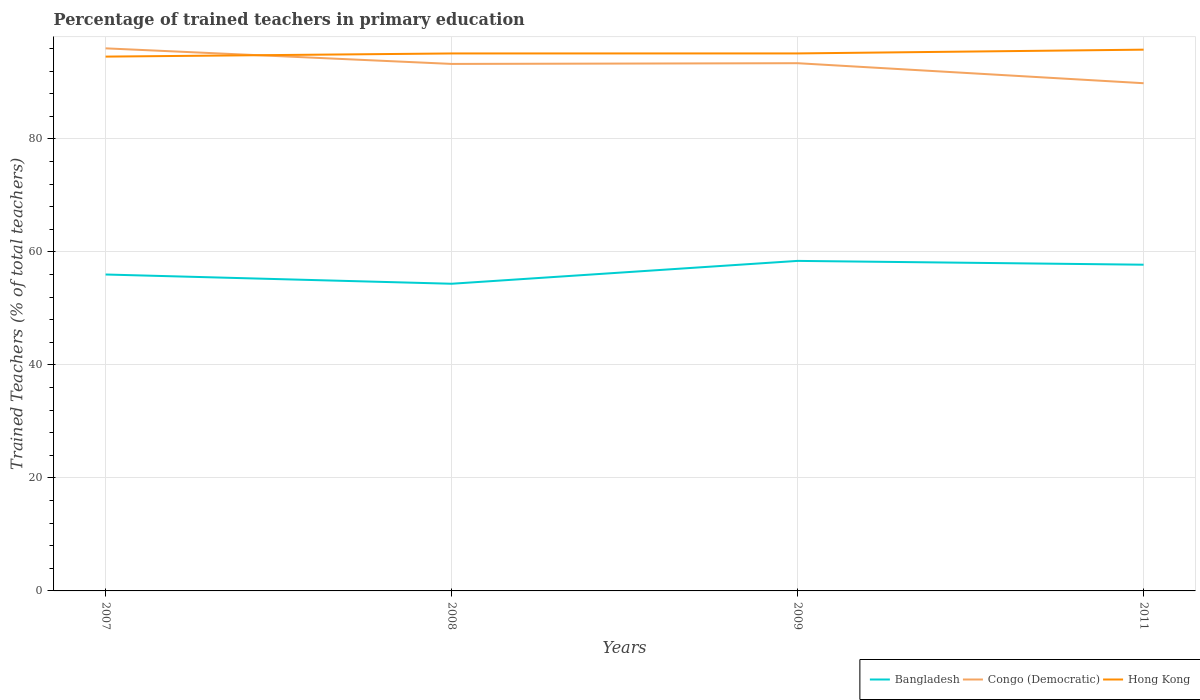How many different coloured lines are there?
Your answer should be very brief. 3. Does the line corresponding to Bangladesh intersect with the line corresponding to Hong Kong?
Make the answer very short. No. Across all years, what is the maximum percentage of trained teachers in Bangladesh?
Offer a very short reply. 54.36. What is the total percentage of trained teachers in Hong Kong in the graph?
Your answer should be very brief. -0.67. What is the difference between the highest and the second highest percentage of trained teachers in Congo (Democratic)?
Provide a short and direct response. 6.17. Is the percentage of trained teachers in Congo (Democratic) strictly greater than the percentage of trained teachers in Hong Kong over the years?
Your response must be concise. No. How many lines are there?
Give a very brief answer. 3. How many years are there in the graph?
Give a very brief answer. 4. What is the difference between two consecutive major ticks on the Y-axis?
Make the answer very short. 20. Are the values on the major ticks of Y-axis written in scientific E-notation?
Provide a succinct answer. No. Where does the legend appear in the graph?
Ensure brevity in your answer.  Bottom right. How many legend labels are there?
Your answer should be very brief. 3. What is the title of the graph?
Offer a terse response. Percentage of trained teachers in primary education. What is the label or title of the Y-axis?
Keep it short and to the point. Trained Teachers (% of total teachers). What is the Trained Teachers (% of total teachers) in Bangladesh in 2007?
Provide a succinct answer. 56. What is the Trained Teachers (% of total teachers) of Congo (Democratic) in 2007?
Your answer should be compact. 96.02. What is the Trained Teachers (% of total teachers) in Hong Kong in 2007?
Give a very brief answer. 94.56. What is the Trained Teachers (% of total teachers) of Bangladesh in 2008?
Your response must be concise. 54.36. What is the Trained Teachers (% of total teachers) of Congo (Democratic) in 2008?
Offer a terse response. 93.27. What is the Trained Teachers (% of total teachers) in Hong Kong in 2008?
Keep it short and to the point. 95.12. What is the Trained Teachers (% of total teachers) in Bangladesh in 2009?
Your answer should be compact. 58.41. What is the Trained Teachers (% of total teachers) in Congo (Democratic) in 2009?
Keep it short and to the point. 93.39. What is the Trained Teachers (% of total teachers) of Hong Kong in 2009?
Your response must be concise. 95.12. What is the Trained Teachers (% of total teachers) of Bangladesh in 2011?
Give a very brief answer. 57.73. What is the Trained Teachers (% of total teachers) in Congo (Democratic) in 2011?
Your response must be concise. 89.85. What is the Trained Teachers (% of total teachers) in Hong Kong in 2011?
Your answer should be very brief. 95.79. Across all years, what is the maximum Trained Teachers (% of total teachers) in Bangladesh?
Your answer should be very brief. 58.41. Across all years, what is the maximum Trained Teachers (% of total teachers) of Congo (Democratic)?
Your response must be concise. 96.02. Across all years, what is the maximum Trained Teachers (% of total teachers) of Hong Kong?
Your answer should be compact. 95.79. Across all years, what is the minimum Trained Teachers (% of total teachers) in Bangladesh?
Ensure brevity in your answer.  54.36. Across all years, what is the minimum Trained Teachers (% of total teachers) of Congo (Democratic)?
Provide a succinct answer. 89.85. Across all years, what is the minimum Trained Teachers (% of total teachers) of Hong Kong?
Make the answer very short. 94.56. What is the total Trained Teachers (% of total teachers) of Bangladesh in the graph?
Your answer should be compact. 226.5. What is the total Trained Teachers (% of total teachers) of Congo (Democratic) in the graph?
Provide a short and direct response. 372.54. What is the total Trained Teachers (% of total teachers) of Hong Kong in the graph?
Give a very brief answer. 380.6. What is the difference between the Trained Teachers (% of total teachers) of Bangladesh in 2007 and that in 2008?
Give a very brief answer. 1.64. What is the difference between the Trained Teachers (% of total teachers) of Congo (Democratic) in 2007 and that in 2008?
Provide a short and direct response. 2.76. What is the difference between the Trained Teachers (% of total teachers) of Hong Kong in 2007 and that in 2008?
Keep it short and to the point. -0.56. What is the difference between the Trained Teachers (% of total teachers) of Bangladesh in 2007 and that in 2009?
Give a very brief answer. -2.41. What is the difference between the Trained Teachers (% of total teachers) of Congo (Democratic) in 2007 and that in 2009?
Keep it short and to the point. 2.63. What is the difference between the Trained Teachers (% of total teachers) of Hong Kong in 2007 and that in 2009?
Offer a terse response. -0.56. What is the difference between the Trained Teachers (% of total teachers) in Bangladesh in 2007 and that in 2011?
Offer a terse response. -1.74. What is the difference between the Trained Teachers (% of total teachers) of Congo (Democratic) in 2007 and that in 2011?
Offer a terse response. 6.17. What is the difference between the Trained Teachers (% of total teachers) of Hong Kong in 2007 and that in 2011?
Your response must be concise. -1.23. What is the difference between the Trained Teachers (% of total teachers) in Bangladesh in 2008 and that in 2009?
Ensure brevity in your answer.  -4.04. What is the difference between the Trained Teachers (% of total teachers) of Congo (Democratic) in 2008 and that in 2009?
Your response must be concise. -0.13. What is the difference between the Trained Teachers (% of total teachers) in Hong Kong in 2008 and that in 2009?
Your answer should be compact. -0. What is the difference between the Trained Teachers (% of total teachers) in Bangladesh in 2008 and that in 2011?
Give a very brief answer. -3.37. What is the difference between the Trained Teachers (% of total teachers) in Congo (Democratic) in 2008 and that in 2011?
Your response must be concise. 3.41. What is the difference between the Trained Teachers (% of total teachers) in Hong Kong in 2008 and that in 2011?
Ensure brevity in your answer.  -0.67. What is the difference between the Trained Teachers (% of total teachers) in Bangladesh in 2009 and that in 2011?
Keep it short and to the point. 0.67. What is the difference between the Trained Teachers (% of total teachers) in Congo (Democratic) in 2009 and that in 2011?
Your response must be concise. 3.54. What is the difference between the Trained Teachers (% of total teachers) of Hong Kong in 2009 and that in 2011?
Give a very brief answer. -0.67. What is the difference between the Trained Teachers (% of total teachers) in Bangladesh in 2007 and the Trained Teachers (% of total teachers) in Congo (Democratic) in 2008?
Your answer should be compact. -37.27. What is the difference between the Trained Teachers (% of total teachers) of Bangladesh in 2007 and the Trained Teachers (% of total teachers) of Hong Kong in 2008?
Offer a very short reply. -39.12. What is the difference between the Trained Teachers (% of total teachers) of Congo (Democratic) in 2007 and the Trained Teachers (% of total teachers) of Hong Kong in 2008?
Your answer should be very brief. 0.9. What is the difference between the Trained Teachers (% of total teachers) in Bangladesh in 2007 and the Trained Teachers (% of total teachers) in Congo (Democratic) in 2009?
Provide a succinct answer. -37.39. What is the difference between the Trained Teachers (% of total teachers) of Bangladesh in 2007 and the Trained Teachers (% of total teachers) of Hong Kong in 2009?
Make the answer very short. -39.13. What is the difference between the Trained Teachers (% of total teachers) of Congo (Democratic) in 2007 and the Trained Teachers (% of total teachers) of Hong Kong in 2009?
Your answer should be very brief. 0.9. What is the difference between the Trained Teachers (% of total teachers) in Bangladesh in 2007 and the Trained Teachers (% of total teachers) in Congo (Democratic) in 2011?
Ensure brevity in your answer.  -33.85. What is the difference between the Trained Teachers (% of total teachers) of Bangladesh in 2007 and the Trained Teachers (% of total teachers) of Hong Kong in 2011?
Offer a terse response. -39.79. What is the difference between the Trained Teachers (% of total teachers) in Congo (Democratic) in 2007 and the Trained Teachers (% of total teachers) in Hong Kong in 2011?
Your answer should be very brief. 0.23. What is the difference between the Trained Teachers (% of total teachers) of Bangladesh in 2008 and the Trained Teachers (% of total teachers) of Congo (Democratic) in 2009?
Offer a terse response. -39.03. What is the difference between the Trained Teachers (% of total teachers) in Bangladesh in 2008 and the Trained Teachers (% of total teachers) in Hong Kong in 2009?
Your answer should be very brief. -40.76. What is the difference between the Trained Teachers (% of total teachers) in Congo (Democratic) in 2008 and the Trained Teachers (% of total teachers) in Hong Kong in 2009?
Offer a terse response. -1.86. What is the difference between the Trained Teachers (% of total teachers) in Bangladesh in 2008 and the Trained Teachers (% of total teachers) in Congo (Democratic) in 2011?
Your answer should be compact. -35.49. What is the difference between the Trained Teachers (% of total teachers) of Bangladesh in 2008 and the Trained Teachers (% of total teachers) of Hong Kong in 2011?
Your response must be concise. -41.43. What is the difference between the Trained Teachers (% of total teachers) in Congo (Democratic) in 2008 and the Trained Teachers (% of total teachers) in Hong Kong in 2011?
Ensure brevity in your answer.  -2.52. What is the difference between the Trained Teachers (% of total teachers) in Bangladesh in 2009 and the Trained Teachers (% of total teachers) in Congo (Democratic) in 2011?
Provide a short and direct response. -31.45. What is the difference between the Trained Teachers (% of total teachers) of Bangladesh in 2009 and the Trained Teachers (% of total teachers) of Hong Kong in 2011?
Give a very brief answer. -37.38. What is the difference between the Trained Teachers (% of total teachers) of Congo (Democratic) in 2009 and the Trained Teachers (% of total teachers) of Hong Kong in 2011?
Keep it short and to the point. -2.4. What is the average Trained Teachers (% of total teachers) of Bangladesh per year?
Make the answer very short. 56.63. What is the average Trained Teachers (% of total teachers) of Congo (Democratic) per year?
Provide a short and direct response. 93.13. What is the average Trained Teachers (% of total teachers) of Hong Kong per year?
Make the answer very short. 95.15. In the year 2007, what is the difference between the Trained Teachers (% of total teachers) in Bangladesh and Trained Teachers (% of total teachers) in Congo (Democratic)?
Provide a short and direct response. -40.02. In the year 2007, what is the difference between the Trained Teachers (% of total teachers) of Bangladesh and Trained Teachers (% of total teachers) of Hong Kong?
Your answer should be compact. -38.56. In the year 2007, what is the difference between the Trained Teachers (% of total teachers) of Congo (Democratic) and Trained Teachers (% of total teachers) of Hong Kong?
Offer a terse response. 1.46. In the year 2008, what is the difference between the Trained Teachers (% of total teachers) of Bangladesh and Trained Teachers (% of total teachers) of Congo (Democratic)?
Offer a terse response. -38.9. In the year 2008, what is the difference between the Trained Teachers (% of total teachers) in Bangladesh and Trained Teachers (% of total teachers) in Hong Kong?
Give a very brief answer. -40.76. In the year 2008, what is the difference between the Trained Teachers (% of total teachers) in Congo (Democratic) and Trained Teachers (% of total teachers) in Hong Kong?
Ensure brevity in your answer.  -1.85. In the year 2009, what is the difference between the Trained Teachers (% of total teachers) of Bangladesh and Trained Teachers (% of total teachers) of Congo (Democratic)?
Provide a short and direct response. -34.99. In the year 2009, what is the difference between the Trained Teachers (% of total teachers) of Bangladesh and Trained Teachers (% of total teachers) of Hong Kong?
Offer a terse response. -36.72. In the year 2009, what is the difference between the Trained Teachers (% of total teachers) of Congo (Democratic) and Trained Teachers (% of total teachers) of Hong Kong?
Make the answer very short. -1.73. In the year 2011, what is the difference between the Trained Teachers (% of total teachers) in Bangladesh and Trained Teachers (% of total teachers) in Congo (Democratic)?
Your response must be concise. -32.12. In the year 2011, what is the difference between the Trained Teachers (% of total teachers) in Bangladesh and Trained Teachers (% of total teachers) in Hong Kong?
Your answer should be very brief. -38.06. In the year 2011, what is the difference between the Trained Teachers (% of total teachers) of Congo (Democratic) and Trained Teachers (% of total teachers) of Hong Kong?
Make the answer very short. -5.94. What is the ratio of the Trained Teachers (% of total teachers) in Bangladesh in 2007 to that in 2008?
Make the answer very short. 1.03. What is the ratio of the Trained Teachers (% of total teachers) in Congo (Democratic) in 2007 to that in 2008?
Make the answer very short. 1.03. What is the ratio of the Trained Teachers (% of total teachers) in Bangladesh in 2007 to that in 2009?
Your answer should be compact. 0.96. What is the ratio of the Trained Teachers (% of total teachers) of Congo (Democratic) in 2007 to that in 2009?
Provide a succinct answer. 1.03. What is the ratio of the Trained Teachers (% of total teachers) of Hong Kong in 2007 to that in 2009?
Your answer should be compact. 0.99. What is the ratio of the Trained Teachers (% of total teachers) of Bangladesh in 2007 to that in 2011?
Provide a succinct answer. 0.97. What is the ratio of the Trained Teachers (% of total teachers) of Congo (Democratic) in 2007 to that in 2011?
Give a very brief answer. 1.07. What is the ratio of the Trained Teachers (% of total teachers) of Hong Kong in 2007 to that in 2011?
Your answer should be very brief. 0.99. What is the ratio of the Trained Teachers (% of total teachers) in Bangladesh in 2008 to that in 2009?
Your answer should be compact. 0.93. What is the ratio of the Trained Teachers (% of total teachers) of Bangladesh in 2008 to that in 2011?
Your response must be concise. 0.94. What is the ratio of the Trained Teachers (% of total teachers) of Congo (Democratic) in 2008 to that in 2011?
Provide a short and direct response. 1.04. What is the ratio of the Trained Teachers (% of total teachers) of Bangladesh in 2009 to that in 2011?
Provide a short and direct response. 1.01. What is the ratio of the Trained Teachers (% of total teachers) in Congo (Democratic) in 2009 to that in 2011?
Your response must be concise. 1.04. What is the ratio of the Trained Teachers (% of total teachers) in Hong Kong in 2009 to that in 2011?
Keep it short and to the point. 0.99. What is the difference between the highest and the second highest Trained Teachers (% of total teachers) in Bangladesh?
Your answer should be very brief. 0.67. What is the difference between the highest and the second highest Trained Teachers (% of total teachers) in Congo (Democratic)?
Provide a short and direct response. 2.63. What is the difference between the highest and the second highest Trained Teachers (% of total teachers) of Hong Kong?
Your response must be concise. 0.67. What is the difference between the highest and the lowest Trained Teachers (% of total teachers) in Bangladesh?
Give a very brief answer. 4.04. What is the difference between the highest and the lowest Trained Teachers (% of total teachers) of Congo (Democratic)?
Ensure brevity in your answer.  6.17. What is the difference between the highest and the lowest Trained Teachers (% of total teachers) in Hong Kong?
Provide a short and direct response. 1.23. 